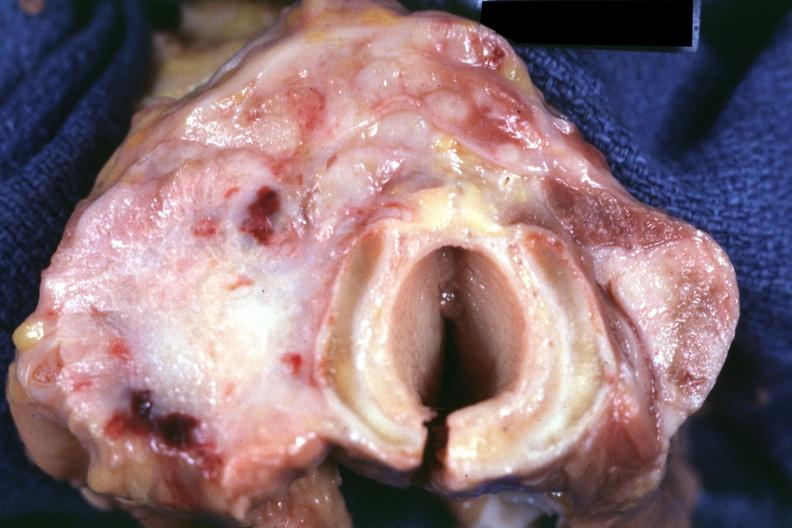s endocrine present?
Answer the question using a single word or phrase. Yes 